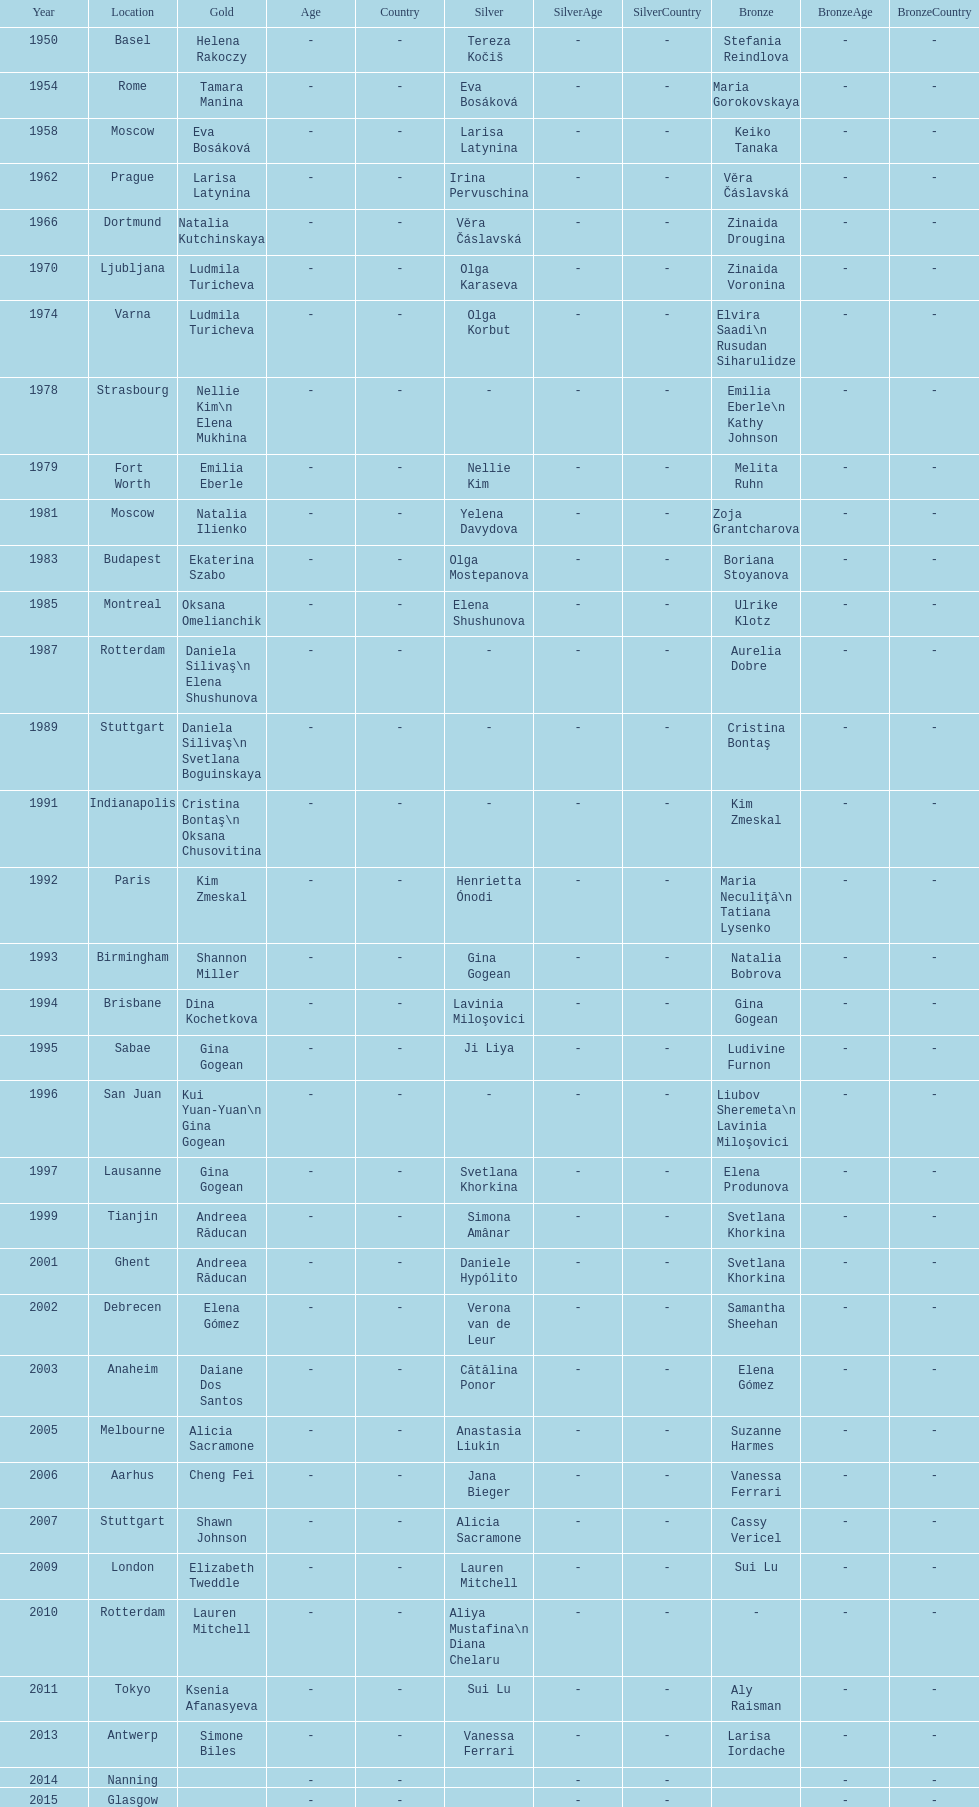How many instances was the place in the united states? 3. 